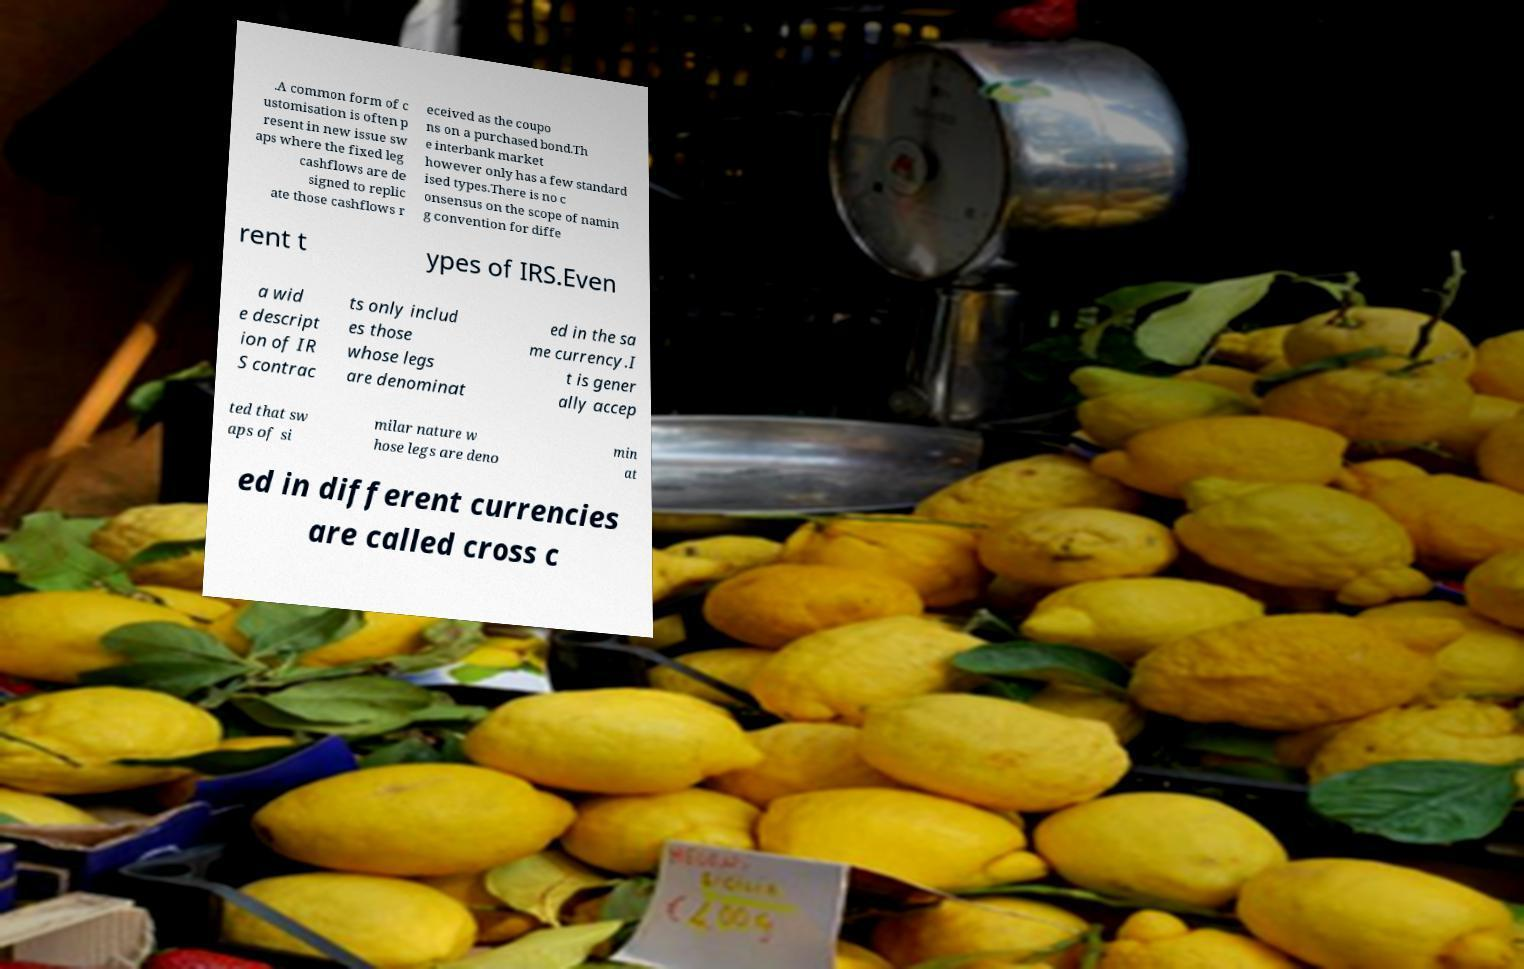What messages or text are displayed in this image? I need them in a readable, typed format. .A common form of c ustomisation is often p resent in new issue sw aps where the fixed leg cashflows are de signed to replic ate those cashflows r eceived as the coupo ns on a purchased bond.Th e interbank market however only has a few standard ised types.There is no c onsensus on the scope of namin g convention for diffe rent t ypes of IRS.Even a wid e descript ion of IR S contrac ts only includ es those whose legs are denominat ed in the sa me currency.I t is gener ally accep ted that sw aps of si milar nature w hose legs are deno min at ed in different currencies are called cross c 